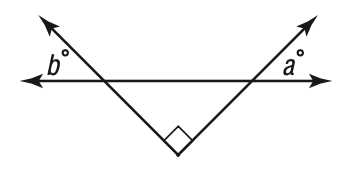Question: Which of the following statements about the figure is true?
Choices:
A. 90 > a + b
B. a + b = 90
C. a + b > 90
D. a > b
Answer with the letter. Answer: B 